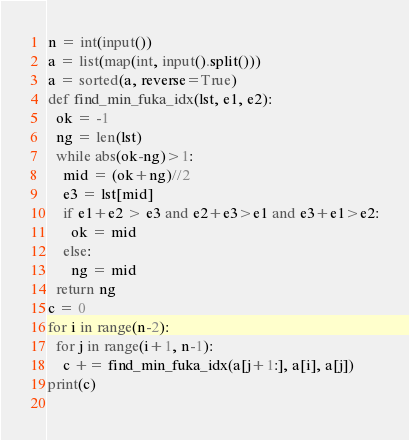<code> <loc_0><loc_0><loc_500><loc_500><_Python_>n = int(input())
a = list(map(int, input().split()))
a = sorted(a, reverse=True)
def find_min_fuka_idx(lst, e1, e2):
  ok = -1
  ng = len(lst)
  while abs(ok-ng)>1:
    mid = (ok+ng)//2
    e3 = lst[mid]
    if e1+e2 > e3 and e2+e3>e1 and e3+e1>e2:
      ok = mid
    else:
      ng = mid
  return ng
c = 0
for i in range(n-2):
  for j in range(i+1, n-1):
    c += find_min_fuka_idx(a[j+1:], a[i], a[j])
print(c)
  </code> 